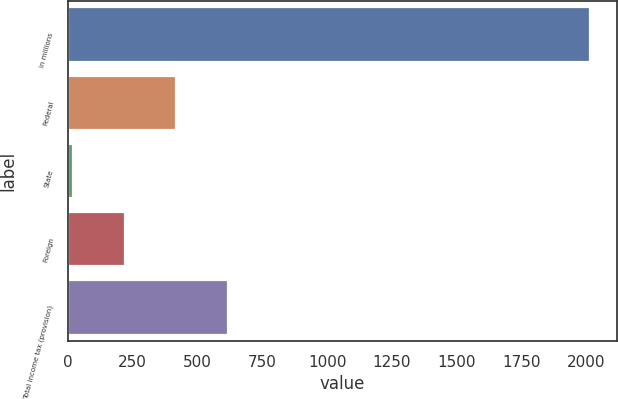Convert chart. <chart><loc_0><loc_0><loc_500><loc_500><bar_chart><fcel>in millions<fcel>Federal<fcel>State<fcel>Foreign<fcel>Total income tax (provision)<nl><fcel>2016<fcel>418.32<fcel>18.9<fcel>218.61<fcel>618.03<nl></chart> 